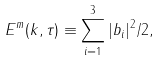Convert formula to latex. <formula><loc_0><loc_0><loc_500><loc_500>E ^ { m } ( { k } , \tau ) \equiv \sum _ { i = 1 } ^ { 3 } | b _ { i } | ^ { 2 } / 2 ,</formula> 